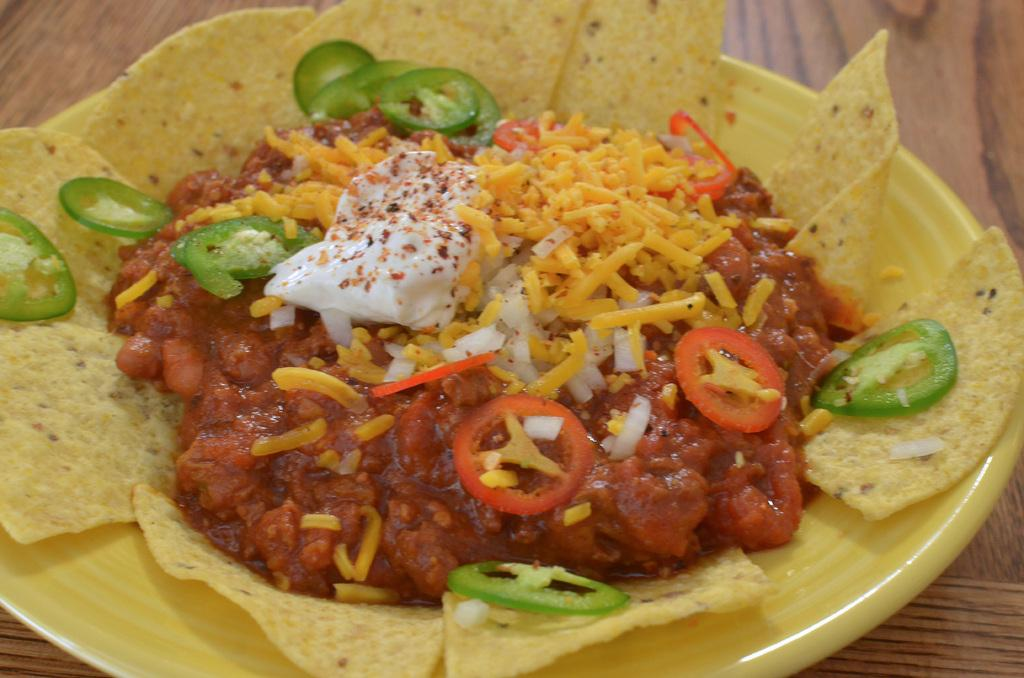What color is the plate in the image? The plate in the image is yellow. What is the plate placed on? The plate is on a wooden surface. What type of food is on the plate? There are nachos on the plate. What additional toppings are on the nachos? There are pieces of chilli, tomato, and white cream on the nachos. Are there any other items on the nachos? Yes, there are other items on the nachos. What type of collar can be seen on the nachos in the image? There is no collar present on the nachos in the image. Are there any feathers visible on the nachos in the image? There are no feathers present on the nachos in the image. 